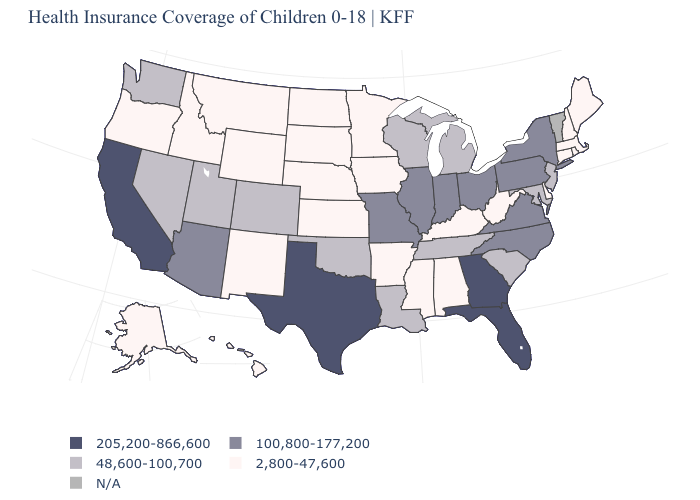Does Florida have the highest value in the USA?
Concise answer only. Yes. Name the states that have a value in the range 2,800-47,600?
Keep it brief. Alabama, Alaska, Arkansas, Connecticut, Delaware, Hawaii, Idaho, Iowa, Kansas, Kentucky, Maine, Massachusetts, Minnesota, Mississippi, Montana, Nebraska, New Hampshire, New Mexico, North Dakota, Oregon, Rhode Island, South Dakota, West Virginia, Wyoming. What is the value of Kansas?
Write a very short answer. 2,800-47,600. Name the states that have a value in the range N/A?
Be succinct. Vermont. Name the states that have a value in the range N/A?
Quick response, please. Vermont. Does Colorado have the lowest value in the USA?
Short answer required. No. What is the value of Tennessee?
Quick response, please. 48,600-100,700. Which states hav the highest value in the West?
Keep it brief. California. Name the states that have a value in the range 2,800-47,600?
Concise answer only. Alabama, Alaska, Arkansas, Connecticut, Delaware, Hawaii, Idaho, Iowa, Kansas, Kentucky, Maine, Massachusetts, Minnesota, Mississippi, Montana, Nebraska, New Hampshire, New Mexico, North Dakota, Oregon, Rhode Island, South Dakota, West Virginia, Wyoming. What is the value of Maryland?
Short answer required. 48,600-100,700. What is the value of Nevada?
Write a very short answer. 48,600-100,700. Does Nebraska have the highest value in the MidWest?
Short answer required. No. What is the value of Ohio?
Answer briefly. 100,800-177,200. What is the value of Michigan?
Concise answer only. 48,600-100,700. Does New York have the lowest value in the Northeast?
Keep it brief. No. 